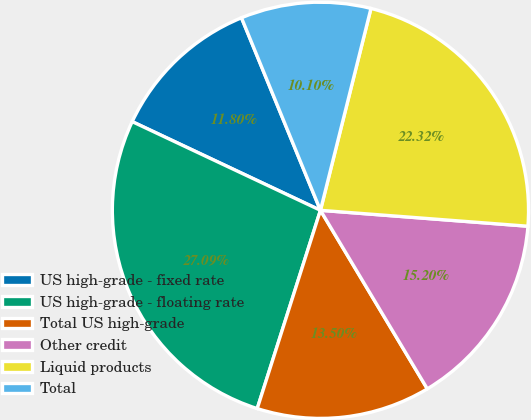Convert chart. <chart><loc_0><loc_0><loc_500><loc_500><pie_chart><fcel>US high-grade - fixed rate<fcel>US high-grade - floating rate<fcel>Total US high-grade<fcel>Other credit<fcel>Liquid products<fcel>Total<nl><fcel>11.8%<fcel>27.1%<fcel>13.5%<fcel>15.2%<fcel>22.32%<fcel>10.1%<nl></chart> 